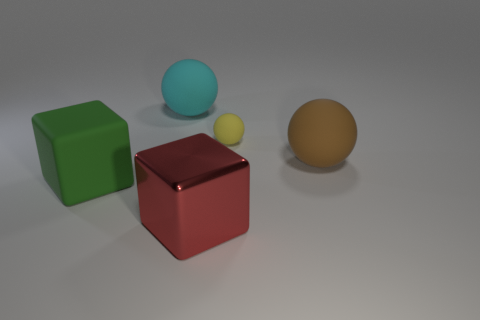Are there any other things that have the same material as the red thing?
Your answer should be very brief. No. Is the number of big green matte things that are behind the large green rubber thing less than the number of large brown rubber cylinders?
Keep it short and to the point. No. Is the color of the big metallic thing the same as the rubber block?
Keep it short and to the point. No. Is there anything else that has the same shape as the yellow object?
Your answer should be compact. Yes. Is the number of big cyan objects less than the number of small blue rubber blocks?
Provide a short and direct response. No. What is the color of the large matte ball on the left side of the large ball in front of the small rubber ball?
Provide a succinct answer. Cyan. The object on the left side of the large sphere that is left of the red metallic block on the left side of the brown thing is made of what material?
Keep it short and to the point. Rubber. There is a cube right of the cyan matte thing; is it the same size as the large cyan object?
Provide a succinct answer. Yes. What is the big block right of the large green block made of?
Ensure brevity in your answer.  Metal. Is the number of gray rubber things greater than the number of balls?
Provide a succinct answer. No. 